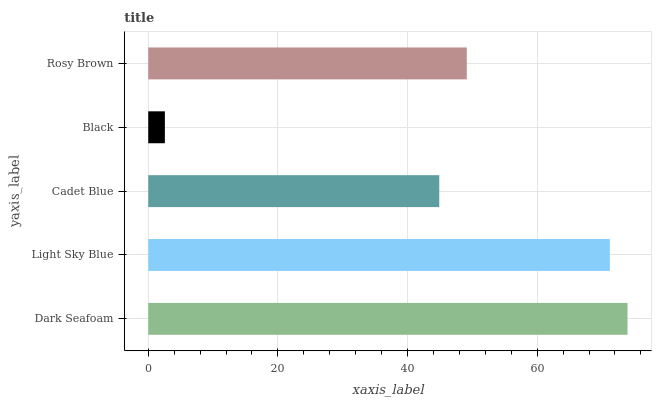Is Black the minimum?
Answer yes or no. Yes. Is Dark Seafoam the maximum?
Answer yes or no. Yes. Is Light Sky Blue the minimum?
Answer yes or no. No. Is Light Sky Blue the maximum?
Answer yes or no. No. Is Dark Seafoam greater than Light Sky Blue?
Answer yes or no. Yes. Is Light Sky Blue less than Dark Seafoam?
Answer yes or no. Yes. Is Light Sky Blue greater than Dark Seafoam?
Answer yes or no. No. Is Dark Seafoam less than Light Sky Blue?
Answer yes or no. No. Is Rosy Brown the high median?
Answer yes or no. Yes. Is Rosy Brown the low median?
Answer yes or no. Yes. Is Cadet Blue the high median?
Answer yes or no. No. Is Light Sky Blue the low median?
Answer yes or no. No. 